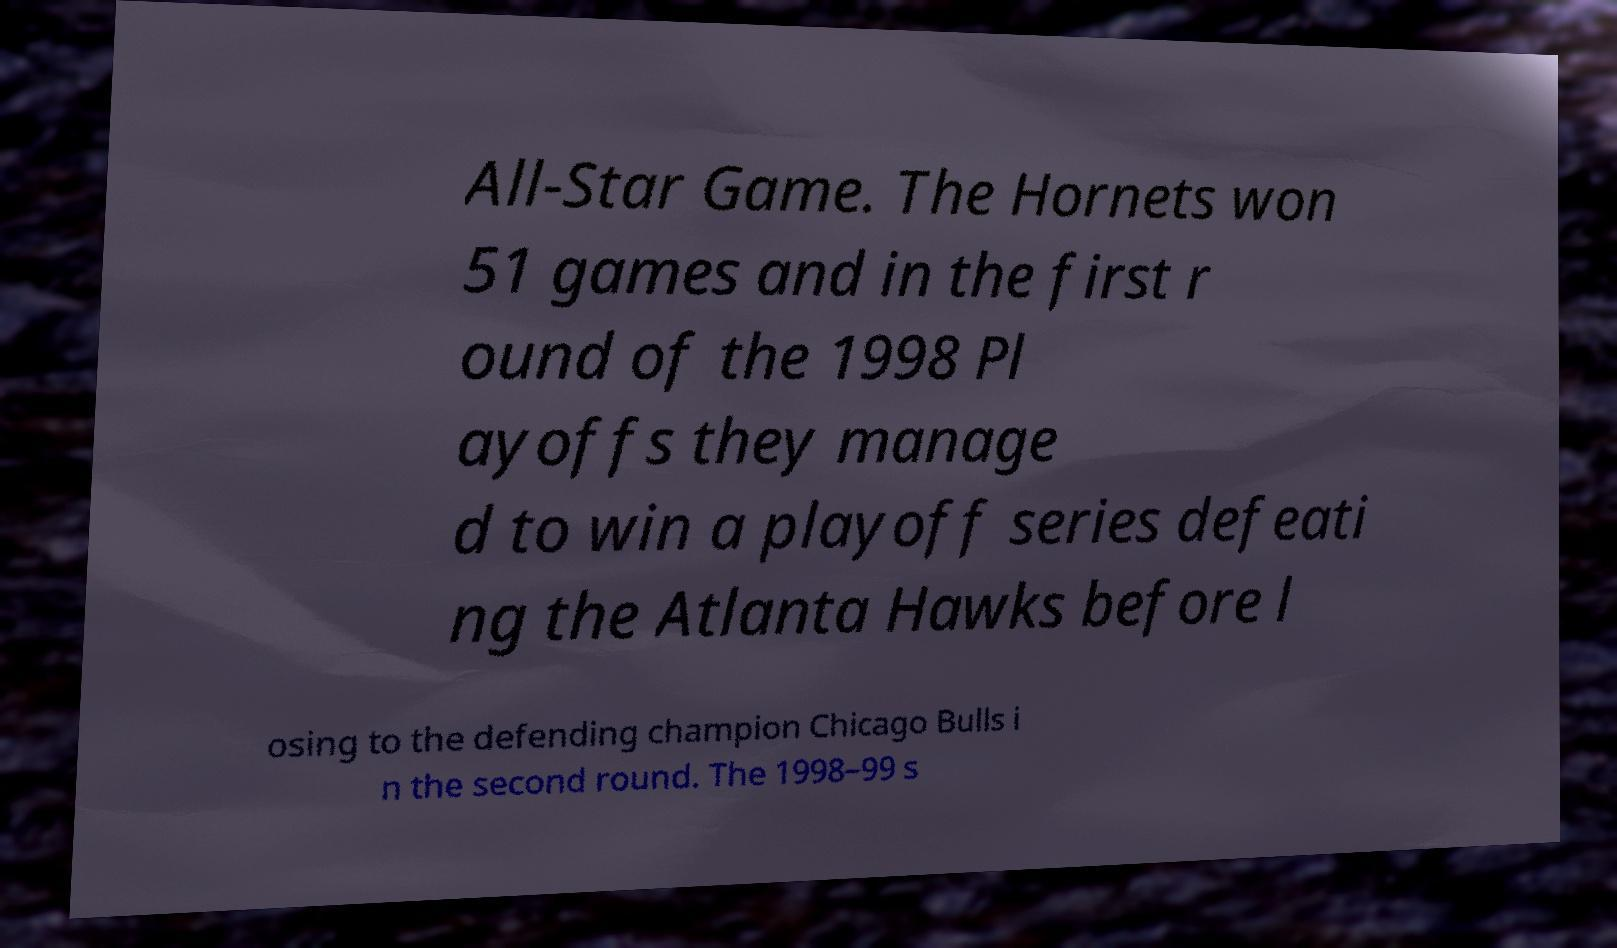I need the written content from this picture converted into text. Can you do that? All-Star Game. The Hornets won 51 games and in the first r ound of the 1998 Pl ayoffs they manage d to win a playoff series defeati ng the Atlanta Hawks before l osing to the defending champion Chicago Bulls i n the second round. The 1998–99 s 